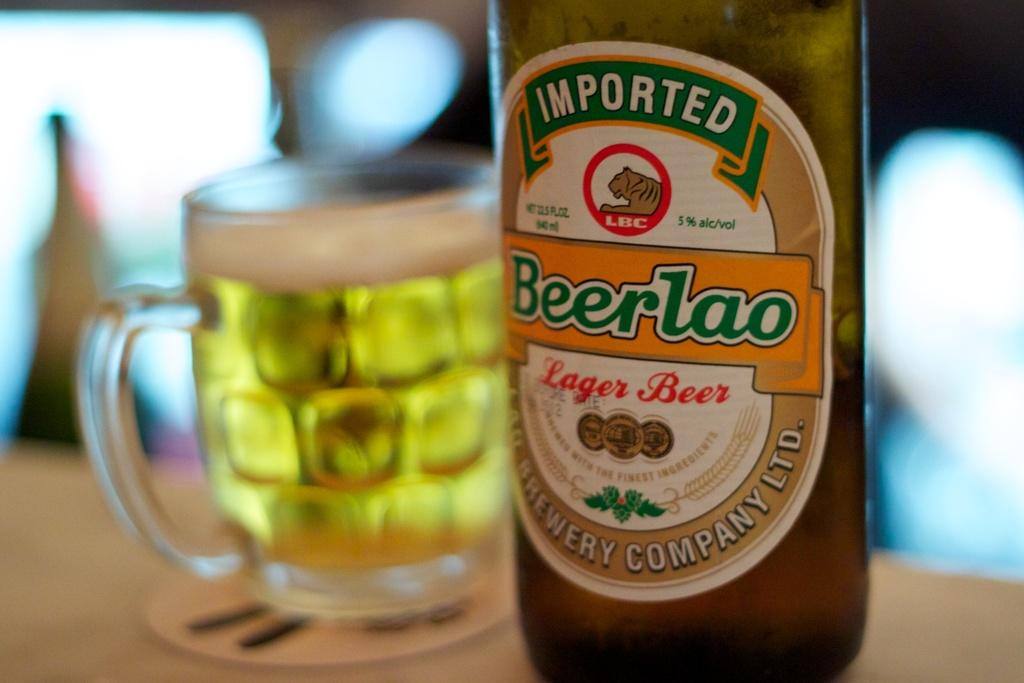<image>
Render a clear and concise summary of the photo. a bottle of imported beerlao lager beer next to a glass full of it 